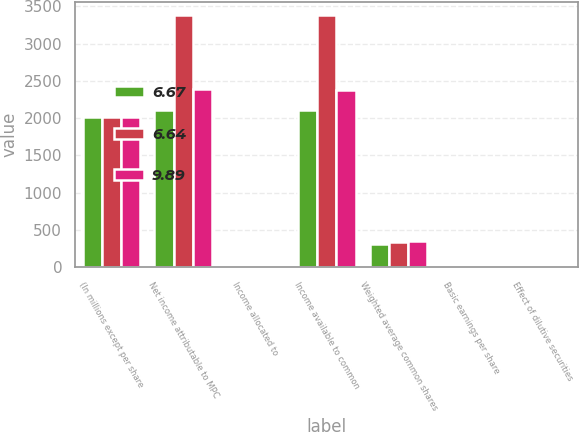<chart> <loc_0><loc_0><loc_500><loc_500><stacked_bar_chart><ecel><fcel>(In millions except per share<fcel>Net income attributable to MPC<fcel>Income allocated to<fcel>Income available to common<fcel>Weighted average common shares<fcel>Basic earnings per share<fcel>Effect of dilutive securities<nl><fcel>6.67<fcel>2013<fcel>2112<fcel>4<fcel>2108<fcel>315<fcel>6.69<fcel>2<nl><fcel>6.64<fcel>2012<fcel>3389<fcel>6<fcel>3383<fcel>340<fcel>9.95<fcel>2<nl><fcel>9.89<fcel>2011<fcel>2389<fcel>4<fcel>2385<fcel>356<fcel>6.7<fcel>1<nl></chart> 